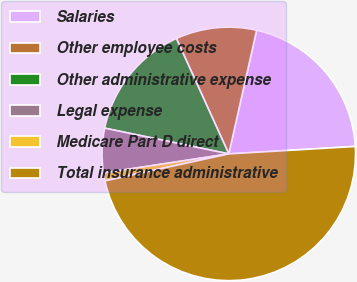Convert chart. <chart><loc_0><loc_0><loc_500><loc_500><pie_chart><fcel>Salaries<fcel>Other employee costs<fcel>Other administrative expense<fcel>Legal expense<fcel>Medicare Part D direct<fcel>Total insurance administrative<nl><fcel>20.54%<fcel>10.31%<fcel>14.96%<fcel>5.66%<fcel>1.01%<fcel>47.52%<nl></chart> 